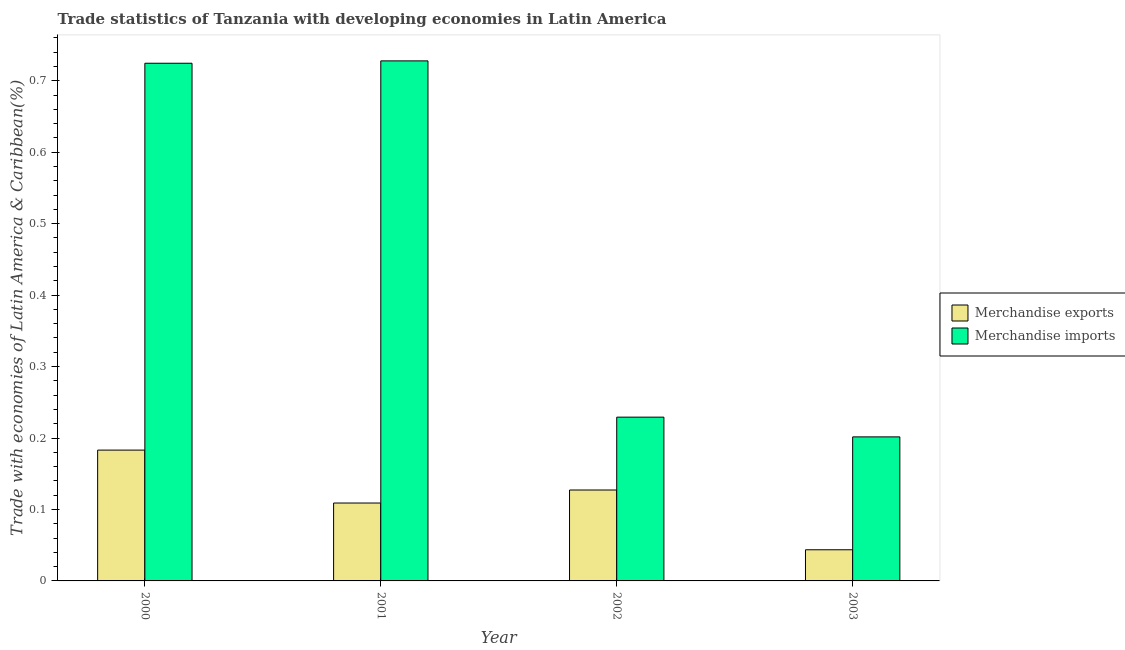How many different coloured bars are there?
Give a very brief answer. 2. How many groups of bars are there?
Keep it short and to the point. 4. Are the number of bars per tick equal to the number of legend labels?
Your answer should be very brief. Yes. How many bars are there on the 2nd tick from the left?
Your answer should be very brief. 2. What is the label of the 2nd group of bars from the left?
Your answer should be very brief. 2001. In how many cases, is the number of bars for a given year not equal to the number of legend labels?
Your response must be concise. 0. What is the merchandise imports in 2000?
Provide a succinct answer. 0.72. Across all years, what is the maximum merchandise imports?
Provide a short and direct response. 0.73. Across all years, what is the minimum merchandise exports?
Make the answer very short. 0.04. In which year was the merchandise exports maximum?
Make the answer very short. 2000. In which year was the merchandise exports minimum?
Provide a short and direct response. 2003. What is the total merchandise imports in the graph?
Ensure brevity in your answer.  1.88. What is the difference between the merchandise exports in 2000 and that in 2002?
Keep it short and to the point. 0.06. What is the difference between the merchandise imports in 2003 and the merchandise exports in 2001?
Your answer should be very brief. -0.53. What is the average merchandise exports per year?
Your answer should be compact. 0.12. In how many years, is the merchandise imports greater than 0.32000000000000006 %?
Your answer should be very brief. 2. What is the ratio of the merchandise imports in 2001 to that in 2003?
Your answer should be compact. 3.61. What is the difference between the highest and the second highest merchandise exports?
Give a very brief answer. 0.06. What is the difference between the highest and the lowest merchandise exports?
Make the answer very short. 0.14. Is the sum of the merchandise imports in 2000 and 2002 greater than the maximum merchandise exports across all years?
Keep it short and to the point. Yes. What does the 2nd bar from the right in 2001 represents?
Your answer should be compact. Merchandise exports. How many bars are there?
Provide a succinct answer. 8. Are all the bars in the graph horizontal?
Your answer should be compact. No. How many years are there in the graph?
Offer a terse response. 4. Does the graph contain any zero values?
Your answer should be compact. No. Does the graph contain grids?
Your answer should be very brief. No. How are the legend labels stacked?
Your response must be concise. Vertical. What is the title of the graph?
Your response must be concise. Trade statistics of Tanzania with developing economies in Latin America. Does "Private funds" appear as one of the legend labels in the graph?
Keep it short and to the point. No. What is the label or title of the Y-axis?
Make the answer very short. Trade with economies of Latin America & Caribbean(%). What is the Trade with economies of Latin America & Caribbean(%) of Merchandise exports in 2000?
Offer a terse response. 0.18. What is the Trade with economies of Latin America & Caribbean(%) in Merchandise imports in 2000?
Give a very brief answer. 0.72. What is the Trade with economies of Latin America & Caribbean(%) of Merchandise exports in 2001?
Your answer should be compact. 0.11. What is the Trade with economies of Latin America & Caribbean(%) of Merchandise imports in 2001?
Give a very brief answer. 0.73. What is the Trade with economies of Latin America & Caribbean(%) in Merchandise exports in 2002?
Give a very brief answer. 0.13. What is the Trade with economies of Latin America & Caribbean(%) of Merchandise imports in 2002?
Offer a very short reply. 0.23. What is the Trade with economies of Latin America & Caribbean(%) of Merchandise exports in 2003?
Provide a succinct answer. 0.04. What is the Trade with economies of Latin America & Caribbean(%) of Merchandise imports in 2003?
Provide a succinct answer. 0.2. Across all years, what is the maximum Trade with economies of Latin America & Caribbean(%) in Merchandise exports?
Offer a terse response. 0.18. Across all years, what is the maximum Trade with economies of Latin America & Caribbean(%) of Merchandise imports?
Your response must be concise. 0.73. Across all years, what is the minimum Trade with economies of Latin America & Caribbean(%) in Merchandise exports?
Give a very brief answer. 0.04. Across all years, what is the minimum Trade with economies of Latin America & Caribbean(%) of Merchandise imports?
Offer a terse response. 0.2. What is the total Trade with economies of Latin America & Caribbean(%) of Merchandise exports in the graph?
Offer a terse response. 0.46. What is the total Trade with economies of Latin America & Caribbean(%) in Merchandise imports in the graph?
Your answer should be compact. 1.88. What is the difference between the Trade with economies of Latin America & Caribbean(%) of Merchandise exports in 2000 and that in 2001?
Give a very brief answer. 0.07. What is the difference between the Trade with economies of Latin America & Caribbean(%) in Merchandise imports in 2000 and that in 2001?
Make the answer very short. -0. What is the difference between the Trade with economies of Latin America & Caribbean(%) in Merchandise exports in 2000 and that in 2002?
Provide a succinct answer. 0.06. What is the difference between the Trade with economies of Latin America & Caribbean(%) in Merchandise imports in 2000 and that in 2002?
Keep it short and to the point. 0.5. What is the difference between the Trade with economies of Latin America & Caribbean(%) in Merchandise exports in 2000 and that in 2003?
Make the answer very short. 0.14. What is the difference between the Trade with economies of Latin America & Caribbean(%) in Merchandise imports in 2000 and that in 2003?
Offer a terse response. 0.52. What is the difference between the Trade with economies of Latin America & Caribbean(%) in Merchandise exports in 2001 and that in 2002?
Ensure brevity in your answer.  -0.02. What is the difference between the Trade with economies of Latin America & Caribbean(%) in Merchandise imports in 2001 and that in 2002?
Offer a very short reply. 0.5. What is the difference between the Trade with economies of Latin America & Caribbean(%) in Merchandise exports in 2001 and that in 2003?
Offer a terse response. 0.07. What is the difference between the Trade with economies of Latin America & Caribbean(%) in Merchandise imports in 2001 and that in 2003?
Give a very brief answer. 0.53. What is the difference between the Trade with economies of Latin America & Caribbean(%) in Merchandise exports in 2002 and that in 2003?
Your answer should be very brief. 0.08. What is the difference between the Trade with economies of Latin America & Caribbean(%) of Merchandise imports in 2002 and that in 2003?
Your answer should be compact. 0.03. What is the difference between the Trade with economies of Latin America & Caribbean(%) in Merchandise exports in 2000 and the Trade with economies of Latin America & Caribbean(%) in Merchandise imports in 2001?
Give a very brief answer. -0.54. What is the difference between the Trade with economies of Latin America & Caribbean(%) in Merchandise exports in 2000 and the Trade with economies of Latin America & Caribbean(%) in Merchandise imports in 2002?
Your answer should be compact. -0.05. What is the difference between the Trade with economies of Latin America & Caribbean(%) in Merchandise exports in 2000 and the Trade with economies of Latin America & Caribbean(%) in Merchandise imports in 2003?
Keep it short and to the point. -0.02. What is the difference between the Trade with economies of Latin America & Caribbean(%) of Merchandise exports in 2001 and the Trade with economies of Latin America & Caribbean(%) of Merchandise imports in 2002?
Offer a very short reply. -0.12. What is the difference between the Trade with economies of Latin America & Caribbean(%) of Merchandise exports in 2001 and the Trade with economies of Latin America & Caribbean(%) of Merchandise imports in 2003?
Ensure brevity in your answer.  -0.09. What is the difference between the Trade with economies of Latin America & Caribbean(%) in Merchandise exports in 2002 and the Trade with economies of Latin America & Caribbean(%) in Merchandise imports in 2003?
Provide a short and direct response. -0.07. What is the average Trade with economies of Latin America & Caribbean(%) in Merchandise exports per year?
Ensure brevity in your answer.  0.12. What is the average Trade with economies of Latin America & Caribbean(%) in Merchandise imports per year?
Provide a short and direct response. 0.47. In the year 2000, what is the difference between the Trade with economies of Latin America & Caribbean(%) in Merchandise exports and Trade with economies of Latin America & Caribbean(%) in Merchandise imports?
Your answer should be compact. -0.54. In the year 2001, what is the difference between the Trade with economies of Latin America & Caribbean(%) in Merchandise exports and Trade with economies of Latin America & Caribbean(%) in Merchandise imports?
Provide a succinct answer. -0.62. In the year 2002, what is the difference between the Trade with economies of Latin America & Caribbean(%) of Merchandise exports and Trade with economies of Latin America & Caribbean(%) of Merchandise imports?
Make the answer very short. -0.1. In the year 2003, what is the difference between the Trade with economies of Latin America & Caribbean(%) in Merchandise exports and Trade with economies of Latin America & Caribbean(%) in Merchandise imports?
Offer a very short reply. -0.16. What is the ratio of the Trade with economies of Latin America & Caribbean(%) in Merchandise exports in 2000 to that in 2001?
Your answer should be compact. 1.68. What is the ratio of the Trade with economies of Latin America & Caribbean(%) in Merchandise imports in 2000 to that in 2001?
Give a very brief answer. 1. What is the ratio of the Trade with economies of Latin America & Caribbean(%) of Merchandise exports in 2000 to that in 2002?
Your answer should be very brief. 1.44. What is the ratio of the Trade with economies of Latin America & Caribbean(%) of Merchandise imports in 2000 to that in 2002?
Your answer should be compact. 3.16. What is the ratio of the Trade with economies of Latin America & Caribbean(%) in Merchandise exports in 2000 to that in 2003?
Give a very brief answer. 4.2. What is the ratio of the Trade with economies of Latin America & Caribbean(%) of Merchandise imports in 2000 to that in 2003?
Your answer should be very brief. 3.59. What is the ratio of the Trade with economies of Latin America & Caribbean(%) in Merchandise exports in 2001 to that in 2002?
Provide a short and direct response. 0.86. What is the ratio of the Trade with economies of Latin America & Caribbean(%) in Merchandise imports in 2001 to that in 2002?
Provide a short and direct response. 3.18. What is the ratio of the Trade with economies of Latin America & Caribbean(%) in Merchandise exports in 2001 to that in 2003?
Your answer should be very brief. 2.5. What is the ratio of the Trade with economies of Latin America & Caribbean(%) in Merchandise imports in 2001 to that in 2003?
Your answer should be very brief. 3.61. What is the ratio of the Trade with economies of Latin America & Caribbean(%) of Merchandise exports in 2002 to that in 2003?
Offer a very short reply. 2.92. What is the ratio of the Trade with economies of Latin America & Caribbean(%) of Merchandise imports in 2002 to that in 2003?
Keep it short and to the point. 1.14. What is the difference between the highest and the second highest Trade with economies of Latin America & Caribbean(%) in Merchandise exports?
Offer a very short reply. 0.06. What is the difference between the highest and the second highest Trade with economies of Latin America & Caribbean(%) of Merchandise imports?
Keep it short and to the point. 0. What is the difference between the highest and the lowest Trade with economies of Latin America & Caribbean(%) in Merchandise exports?
Offer a terse response. 0.14. What is the difference between the highest and the lowest Trade with economies of Latin America & Caribbean(%) of Merchandise imports?
Give a very brief answer. 0.53. 